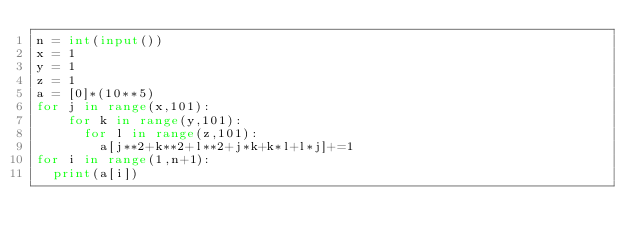<code> <loc_0><loc_0><loc_500><loc_500><_Python_>n = int(input())
x = 1
y = 1
z = 1
a = [0]*(10**5)
for j in range(x,101):
    for k in range(y,101):
      for l in range(z,101):
        a[j**2+k**2+l**2+j*k+k*l+l*j]+=1
for i in range(1,n+1):
  print(a[i])</code> 